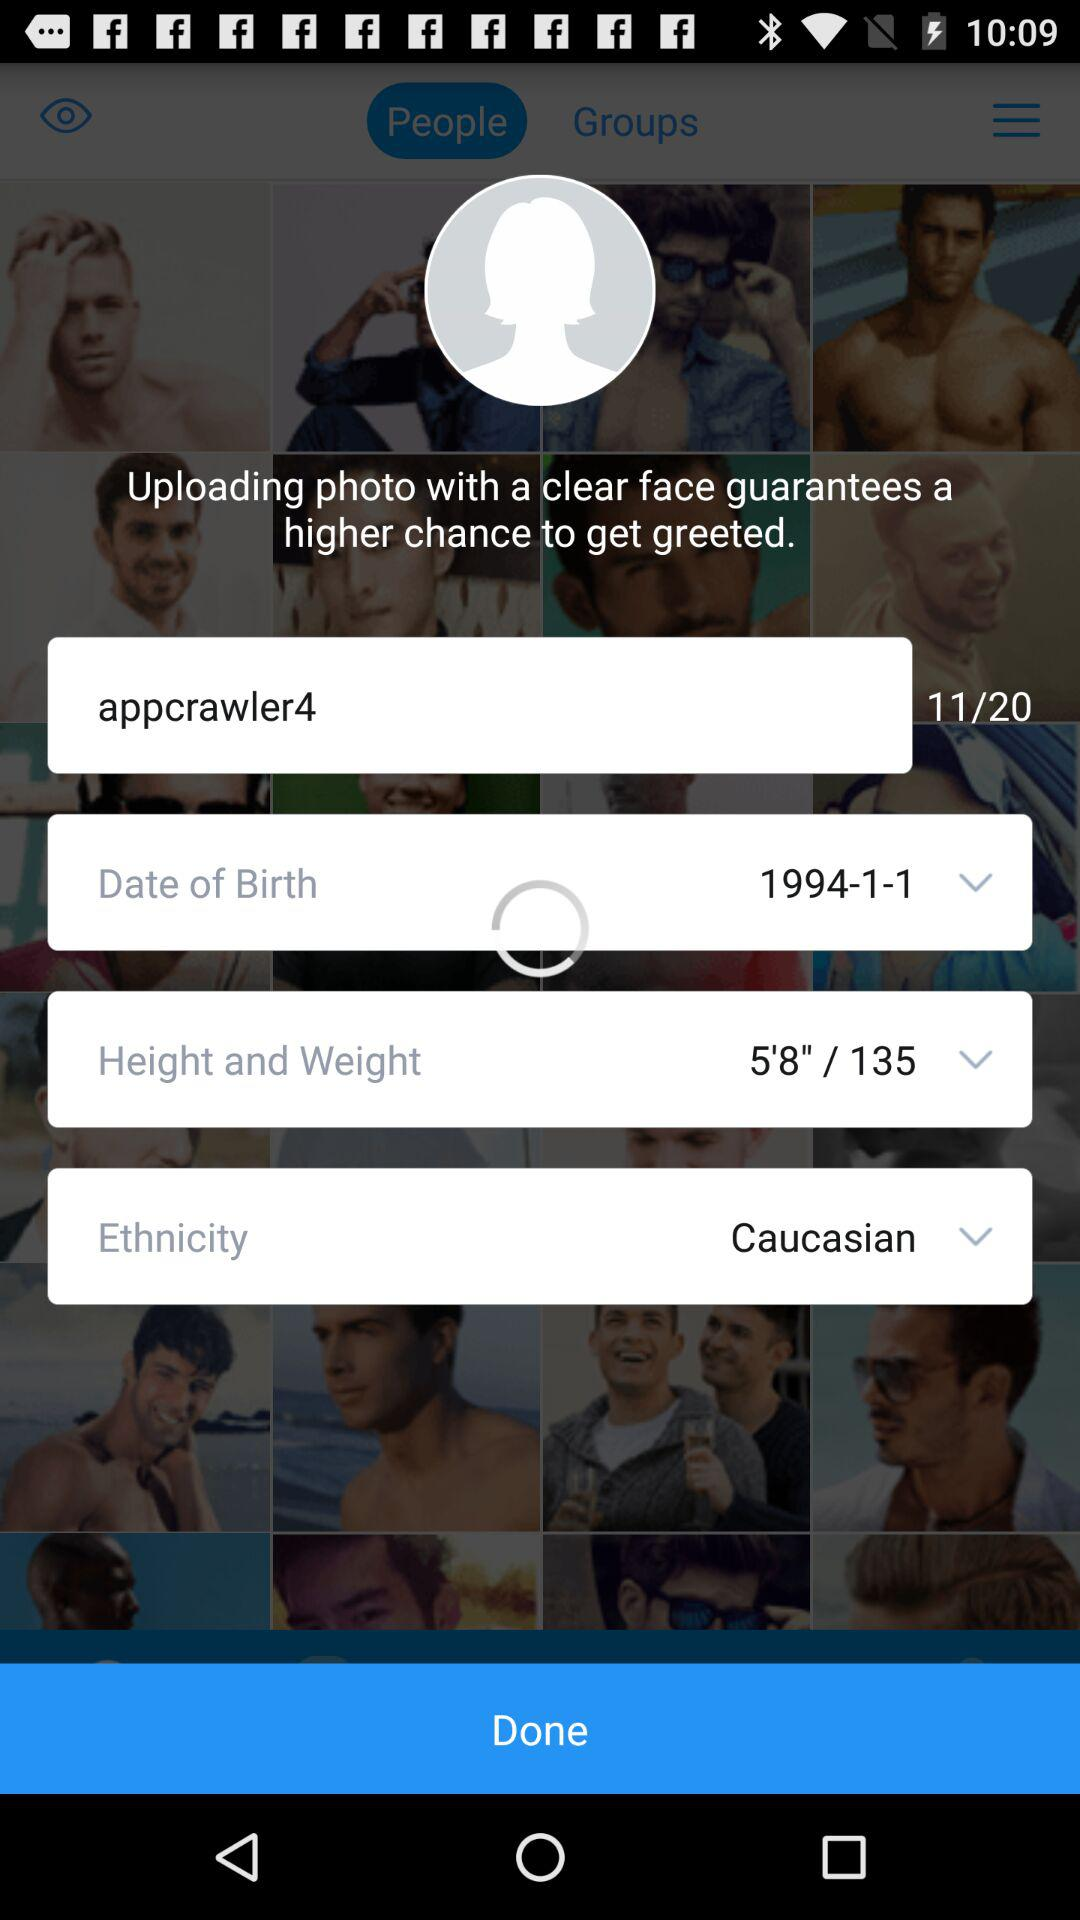What is the name of the user? The name of the user is John. 